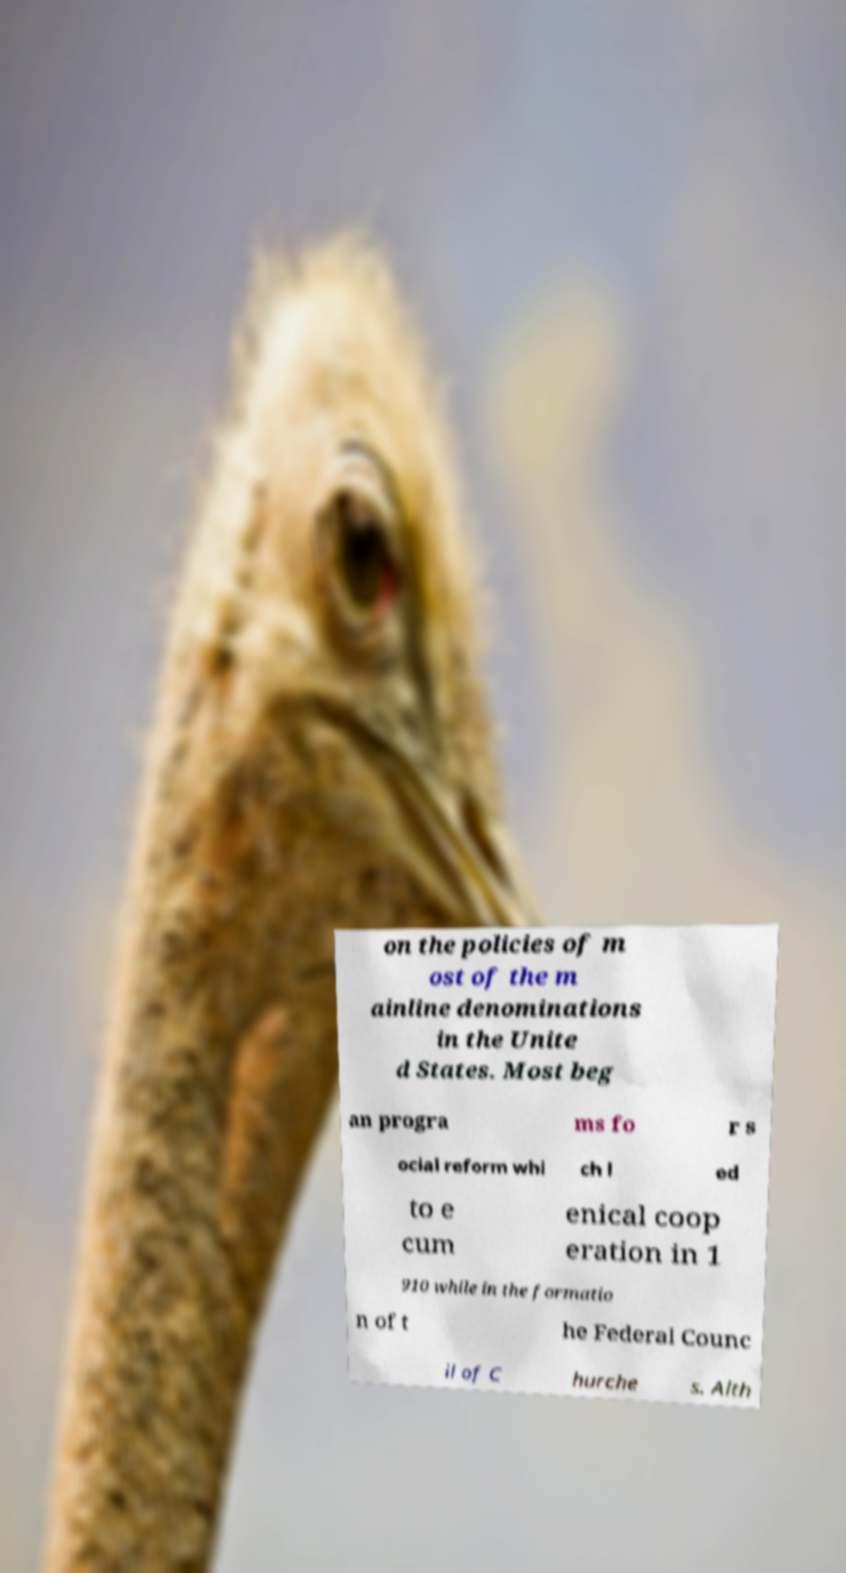Please identify and transcribe the text found in this image. on the policies of m ost of the m ainline denominations in the Unite d States. Most beg an progra ms fo r s ocial reform whi ch l ed to e cum enical coop eration in 1 910 while in the formatio n of t he Federal Counc il of C hurche s. Alth 